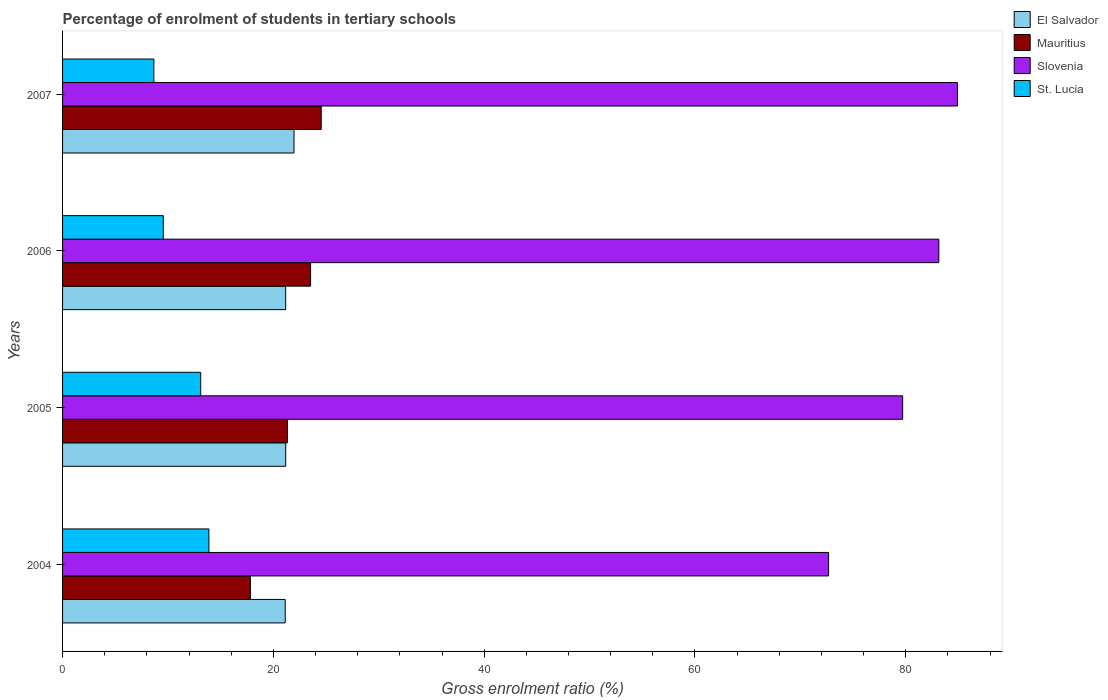How many bars are there on the 1st tick from the bottom?
Provide a succinct answer. 4. What is the percentage of students enrolled in tertiary schools in El Salvador in 2007?
Give a very brief answer. 21.96. Across all years, what is the maximum percentage of students enrolled in tertiary schools in Slovenia?
Keep it short and to the point. 84.91. Across all years, what is the minimum percentage of students enrolled in tertiary schools in Slovenia?
Keep it short and to the point. 72.68. In which year was the percentage of students enrolled in tertiary schools in El Salvador minimum?
Offer a very short reply. 2004. What is the total percentage of students enrolled in tertiary schools in El Salvador in the graph?
Keep it short and to the point. 85.42. What is the difference between the percentage of students enrolled in tertiary schools in Slovenia in 2004 and that in 2007?
Provide a succinct answer. -12.22. What is the difference between the percentage of students enrolled in tertiary schools in El Salvador in 2004 and the percentage of students enrolled in tertiary schools in St. Lucia in 2007?
Your answer should be very brief. 12.46. What is the average percentage of students enrolled in tertiary schools in St. Lucia per year?
Make the answer very short. 11.3. In the year 2004, what is the difference between the percentage of students enrolled in tertiary schools in Slovenia and percentage of students enrolled in tertiary schools in St. Lucia?
Keep it short and to the point. 58.8. What is the ratio of the percentage of students enrolled in tertiary schools in El Salvador in 2004 to that in 2007?
Make the answer very short. 0.96. Is the percentage of students enrolled in tertiary schools in Slovenia in 2004 less than that in 2007?
Give a very brief answer. Yes. What is the difference between the highest and the second highest percentage of students enrolled in tertiary schools in St. Lucia?
Provide a succinct answer. 0.78. What is the difference between the highest and the lowest percentage of students enrolled in tertiary schools in El Salvador?
Make the answer very short. 0.83. In how many years, is the percentage of students enrolled in tertiary schools in St. Lucia greater than the average percentage of students enrolled in tertiary schools in St. Lucia taken over all years?
Provide a short and direct response. 2. Is it the case that in every year, the sum of the percentage of students enrolled in tertiary schools in Mauritius and percentage of students enrolled in tertiary schools in St. Lucia is greater than the sum of percentage of students enrolled in tertiary schools in Slovenia and percentage of students enrolled in tertiary schools in El Salvador?
Your answer should be compact. Yes. What does the 3rd bar from the top in 2007 represents?
Your answer should be very brief. Mauritius. What does the 4th bar from the bottom in 2007 represents?
Provide a short and direct response. St. Lucia. Is it the case that in every year, the sum of the percentage of students enrolled in tertiary schools in Slovenia and percentage of students enrolled in tertiary schools in Mauritius is greater than the percentage of students enrolled in tertiary schools in St. Lucia?
Provide a succinct answer. Yes. Does the graph contain any zero values?
Your answer should be very brief. No. Does the graph contain grids?
Your answer should be compact. No. Where does the legend appear in the graph?
Your answer should be very brief. Top right. How many legend labels are there?
Ensure brevity in your answer.  4. What is the title of the graph?
Your response must be concise. Percentage of enrolment of students in tertiary schools. What is the label or title of the X-axis?
Make the answer very short. Gross enrolment ratio (%). What is the label or title of the Y-axis?
Offer a terse response. Years. What is the Gross enrolment ratio (%) of El Salvador in 2004?
Provide a succinct answer. 21.13. What is the Gross enrolment ratio (%) in Mauritius in 2004?
Offer a terse response. 17.82. What is the Gross enrolment ratio (%) of Slovenia in 2004?
Make the answer very short. 72.68. What is the Gross enrolment ratio (%) in St. Lucia in 2004?
Ensure brevity in your answer.  13.88. What is the Gross enrolment ratio (%) in El Salvador in 2005?
Provide a succinct answer. 21.17. What is the Gross enrolment ratio (%) of Mauritius in 2005?
Provide a short and direct response. 21.34. What is the Gross enrolment ratio (%) in Slovenia in 2005?
Ensure brevity in your answer.  79.71. What is the Gross enrolment ratio (%) in St. Lucia in 2005?
Keep it short and to the point. 13.11. What is the Gross enrolment ratio (%) of El Salvador in 2006?
Your answer should be compact. 21.17. What is the Gross enrolment ratio (%) in Mauritius in 2006?
Make the answer very short. 23.53. What is the Gross enrolment ratio (%) in Slovenia in 2006?
Your answer should be compact. 83.14. What is the Gross enrolment ratio (%) in St. Lucia in 2006?
Your response must be concise. 9.56. What is the Gross enrolment ratio (%) of El Salvador in 2007?
Offer a terse response. 21.96. What is the Gross enrolment ratio (%) in Mauritius in 2007?
Your answer should be compact. 24.54. What is the Gross enrolment ratio (%) of Slovenia in 2007?
Keep it short and to the point. 84.91. What is the Gross enrolment ratio (%) of St. Lucia in 2007?
Provide a short and direct response. 8.66. Across all years, what is the maximum Gross enrolment ratio (%) of El Salvador?
Offer a terse response. 21.96. Across all years, what is the maximum Gross enrolment ratio (%) of Mauritius?
Make the answer very short. 24.54. Across all years, what is the maximum Gross enrolment ratio (%) of Slovenia?
Your answer should be compact. 84.91. Across all years, what is the maximum Gross enrolment ratio (%) of St. Lucia?
Keep it short and to the point. 13.88. Across all years, what is the minimum Gross enrolment ratio (%) of El Salvador?
Your answer should be compact. 21.13. Across all years, what is the minimum Gross enrolment ratio (%) in Mauritius?
Your answer should be compact. 17.82. Across all years, what is the minimum Gross enrolment ratio (%) in Slovenia?
Provide a succinct answer. 72.68. Across all years, what is the minimum Gross enrolment ratio (%) in St. Lucia?
Provide a short and direct response. 8.66. What is the total Gross enrolment ratio (%) of El Salvador in the graph?
Provide a short and direct response. 85.42. What is the total Gross enrolment ratio (%) of Mauritius in the graph?
Your answer should be very brief. 87.23. What is the total Gross enrolment ratio (%) in Slovenia in the graph?
Make the answer very short. 320.43. What is the total Gross enrolment ratio (%) in St. Lucia in the graph?
Offer a terse response. 45.21. What is the difference between the Gross enrolment ratio (%) in El Salvador in 2004 and that in 2005?
Your answer should be very brief. -0.04. What is the difference between the Gross enrolment ratio (%) in Mauritius in 2004 and that in 2005?
Make the answer very short. -3.51. What is the difference between the Gross enrolment ratio (%) in Slovenia in 2004 and that in 2005?
Your answer should be compact. -7.03. What is the difference between the Gross enrolment ratio (%) in St. Lucia in 2004 and that in 2005?
Your answer should be very brief. 0.78. What is the difference between the Gross enrolment ratio (%) of El Salvador in 2004 and that in 2006?
Your answer should be compact. -0.04. What is the difference between the Gross enrolment ratio (%) of Mauritius in 2004 and that in 2006?
Your answer should be compact. -5.71. What is the difference between the Gross enrolment ratio (%) of Slovenia in 2004 and that in 2006?
Your answer should be compact. -10.46. What is the difference between the Gross enrolment ratio (%) of St. Lucia in 2004 and that in 2006?
Make the answer very short. 4.32. What is the difference between the Gross enrolment ratio (%) of El Salvador in 2004 and that in 2007?
Offer a terse response. -0.83. What is the difference between the Gross enrolment ratio (%) in Mauritius in 2004 and that in 2007?
Your response must be concise. -6.72. What is the difference between the Gross enrolment ratio (%) in Slovenia in 2004 and that in 2007?
Your answer should be very brief. -12.22. What is the difference between the Gross enrolment ratio (%) of St. Lucia in 2004 and that in 2007?
Your answer should be very brief. 5.22. What is the difference between the Gross enrolment ratio (%) of El Salvador in 2005 and that in 2006?
Provide a succinct answer. 0. What is the difference between the Gross enrolment ratio (%) in Mauritius in 2005 and that in 2006?
Make the answer very short. -2.2. What is the difference between the Gross enrolment ratio (%) of Slovenia in 2005 and that in 2006?
Offer a very short reply. -3.43. What is the difference between the Gross enrolment ratio (%) in St. Lucia in 2005 and that in 2006?
Your response must be concise. 3.55. What is the difference between the Gross enrolment ratio (%) of El Salvador in 2005 and that in 2007?
Your answer should be compact. -0.79. What is the difference between the Gross enrolment ratio (%) in Mauritius in 2005 and that in 2007?
Your answer should be compact. -3.2. What is the difference between the Gross enrolment ratio (%) of Slovenia in 2005 and that in 2007?
Make the answer very short. -5.2. What is the difference between the Gross enrolment ratio (%) of St. Lucia in 2005 and that in 2007?
Offer a terse response. 4.44. What is the difference between the Gross enrolment ratio (%) in El Salvador in 2006 and that in 2007?
Offer a very short reply. -0.8. What is the difference between the Gross enrolment ratio (%) of Mauritius in 2006 and that in 2007?
Keep it short and to the point. -1.01. What is the difference between the Gross enrolment ratio (%) in Slovenia in 2006 and that in 2007?
Your answer should be compact. -1.77. What is the difference between the Gross enrolment ratio (%) of St. Lucia in 2006 and that in 2007?
Make the answer very short. 0.89. What is the difference between the Gross enrolment ratio (%) of El Salvador in 2004 and the Gross enrolment ratio (%) of Mauritius in 2005?
Keep it short and to the point. -0.21. What is the difference between the Gross enrolment ratio (%) of El Salvador in 2004 and the Gross enrolment ratio (%) of Slovenia in 2005?
Your answer should be very brief. -58.58. What is the difference between the Gross enrolment ratio (%) in El Salvador in 2004 and the Gross enrolment ratio (%) in St. Lucia in 2005?
Keep it short and to the point. 8.02. What is the difference between the Gross enrolment ratio (%) in Mauritius in 2004 and the Gross enrolment ratio (%) in Slovenia in 2005?
Ensure brevity in your answer.  -61.89. What is the difference between the Gross enrolment ratio (%) in Mauritius in 2004 and the Gross enrolment ratio (%) in St. Lucia in 2005?
Give a very brief answer. 4.72. What is the difference between the Gross enrolment ratio (%) in Slovenia in 2004 and the Gross enrolment ratio (%) in St. Lucia in 2005?
Provide a short and direct response. 59.57. What is the difference between the Gross enrolment ratio (%) in El Salvador in 2004 and the Gross enrolment ratio (%) in Mauritius in 2006?
Your answer should be very brief. -2.41. What is the difference between the Gross enrolment ratio (%) of El Salvador in 2004 and the Gross enrolment ratio (%) of Slovenia in 2006?
Make the answer very short. -62.01. What is the difference between the Gross enrolment ratio (%) of El Salvador in 2004 and the Gross enrolment ratio (%) of St. Lucia in 2006?
Ensure brevity in your answer.  11.57. What is the difference between the Gross enrolment ratio (%) of Mauritius in 2004 and the Gross enrolment ratio (%) of Slovenia in 2006?
Your answer should be compact. -65.32. What is the difference between the Gross enrolment ratio (%) in Mauritius in 2004 and the Gross enrolment ratio (%) in St. Lucia in 2006?
Make the answer very short. 8.26. What is the difference between the Gross enrolment ratio (%) of Slovenia in 2004 and the Gross enrolment ratio (%) of St. Lucia in 2006?
Your response must be concise. 63.12. What is the difference between the Gross enrolment ratio (%) of El Salvador in 2004 and the Gross enrolment ratio (%) of Mauritius in 2007?
Your answer should be compact. -3.41. What is the difference between the Gross enrolment ratio (%) of El Salvador in 2004 and the Gross enrolment ratio (%) of Slovenia in 2007?
Give a very brief answer. -63.78. What is the difference between the Gross enrolment ratio (%) of El Salvador in 2004 and the Gross enrolment ratio (%) of St. Lucia in 2007?
Make the answer very short. 12.46. What is the difference between the Gross enrolment ratio (%) in Mauritius in 2004 and the Gross enrolment ratio (%) in Slovenia in 2007?
Offer a terse response. -67.08. What is the difference between the Gross enrolment ratio (%) of Mauritius in 2004 and the Gross enrolment ratio (%) of St. Lucia in 2007?
Your answer should be very brief. 9.16. What is the difference between the Gross enrolment ratio (%) of Slovenia in 2004 and the Gross enrolment ratio (%) of St. Lucia in 2007?
Offer a very short reply. 64.02. What is the difference between the Gross enrolment ratio (%) of El Salvador in 2005 and the Gross enrolment ratio (%) of Mauritius in 2006?
Offer a terse response. -2.36. What is the difference between the Gross enrolment ratio (%) in El Salvador in 2005 and the Gross enrolment ratio (%) in Slovenia in 2006?
Ensure brevity in your answer.  -61.97. What is the difference between the Gross enrolment ratio (%) in El Salvador in 2005 and the Gross enrolment ratio (%) in St. Lucia in 2006?
Your answer should be very brief. 11.61. What is the difference between the Gross enrolment ratio (%) of Mauritius in 2005 and the Gross enrolment ratio (%) of Slovenia in 2006?
Keep it short and to the point. -61.8. What is the difference between the Gross enrolment ratio (%) in Mauritius in 2005 and the Gross enrolment ratio (%) in St. Lucia in 2006?
Offer a terse response. 11.78. What is the difference between the Gross enrolment ratio (%) of Slovenia in 2005 and the Gross enrolment ratio (%) of St. Lucia in 2006?
Keep it short and to the point. 70.15. What is the difference between the Gross enrolment ratio (%) of El Salvador in 2005 and the Gross enrolment ratio (%) of Mauritius in 2007?
Provide a short and direct response. -3.37. What is the difference between the Gross enrolment ratio (%) of El Salvador in 2005 and the Gross enrolment ratio (%) of Slovenia in 2007?
Provide a short and direct response. -63.74. What is the difference between the Gross enrolment ratio (%) in El Salvador in 2005 and the Gross enrolment ratio (%) in St. Lucia in 2007?
Offer a very short reply. 12.51. What is the difference between the Gross enrolment ratio (%) in Mauritius in 2005 and the Gross enrolment ratio (%) in Slovenia in 2007?
Ensure brevity in your answer.  -63.57. What is the difference between the Gross enrolment ratio (%) of Mauritius in 2005 and the Gross enrolment ratio (%) of St. Lucia in 2007?
Give a very brief answer. 12.67. What is the difference between the Gross enrolment ratio (%) in Slovenia in 2005 and the Gross enrolment ratio (%) in St. Lucia in 2007?
Offer a very short reply. 71.04. What is the difference between the Gross enrolment ratio (%) of El Salvador in 2006 and the Gross enrolment ratio (%) of Mauritius in 2007?
Your response must be concise. -3.37. What is the difference between the Gross enrolment ratio (%) of El Salvador in 2006 and the Gross enrolment ratio (%) of Slovenia in 2007?
Make the answer very short. -63.74. What is the difference between the Gross enrolment ratio (%) in El Salvador in 2006 and the Gross enrolment ratio (%) in St. Lucia in 2007?
Provide a short and direct response. 12.5. What is the difference between the Gross enrolment ratio (%) of Mauritius in 2006 and the Gross enrolment ratio (%) of Slovenia in 2007?
Offer a very short reply. -61.37. What is the difference between the Gross enrolment ratio (%) in Mauritius in 2006 and the Gross enrolment ratio (%) in St. Lucia in 2007?
Keep it short and to the point. 14.87. What is the difference between the Gross enrolment ratio (%) in Slovenia in 2006 and the Gross enrolment ratio (%) in St. Lucia in 2007?
Your answer should be very brief. 74.48. What is the average Gross enrolment ratio (%) in El Salvador per year?
Your answer should be compact. 21.36. What is the average Gross enrolment ratio (%) of Mauritius per year?
Provide a succinct answer. 21.81. What is the average Gross enrolment ratio (%) in Slovenia per year?
Your response must be concise. 80.11. What is the average Gross enrolment ratio (%) in St. Lucia per year?
Give a very brief answer. 11.3. In the year 2004, what is the difference between the Gross enrolment ratio (%) of El Salvador and Gross enrolment ratio (%) of Mauritius?
Give a very brief answer. 3.3. In the year 2004, what is the difference between the Gross enrolment ratio (%) of El Salvador and Gross enrolment ratio (%) of Slovenia?
Offer a very short reply. -51.55. In the year 2004, what is the difference between the Gross enrolment ratio (%) of El Salvador and Gross enrolment ratio (%) of St. Lucia?
Keep it short and to the point. 7.24. In the year 2004, what is the difference between the Gross enrolment ratio (%) in Mauritius and Gross enrolment ratio (%) in Slovenia?
Your answer should be compact. -54.86. In the year 2004, what is the difference between the Gross enrolment ratio (%) in Mauritius and Gross enrolment ratio (%) in St. Lucia?
Offer a very short reply. 3.94. In the year 2004, what is the difference between the Gross enrolment ratio (%) in Slovenia and Gross enrolment ratio (%) in St. Lucia?
Keep it short and to the point. 58.8. In the year 2005, what is the difference between the Gross enrolment ratio (%) in El Salvador and Gross enrolment ratio (%) in Mauritius?
Your answer should be very brief. -0.17. In the year 2005, what is the difference between the Gross enrolment ratio (%) of El Salvador and Gross enrolment ratio (%) of Slovenia?
Give a very brief answer. -58.54. In the year 2005, what is the difference between the Gross enrolment ratio (%) of El Salvador and Gross enrolment ratio (%) of St. Lucia?
Your answer should be very brief. 8.06. In the year 2005, what is the difference between the Gross enrolment ratio (%) of Mauritius and Gross enrolment ratio (%) of Slovenia?
Give a very brief answer. -58.37. In the year 2005, what is the difference between the Gross enrolment ratio (%) in Mauritius and Gross enrolment ratio (%) in St. Lucia?
Make the answer very short. 8.23. In the year 2005, what is the difference between the Gross enrolment ratio (%) of Slovenia and Gross enrolment ratio (%) of St. Lucia?
Ensure brevity in your answer.  66.6. In the year 2006, what is the difference between the Gross enrolment ratio (%) of El Salvador and Gross enrolment ratio (%) of Mauritius?
Keep it short and to the point. -2.37. In the year 2006, what is the difference between the Gross enrolment ratio (%) in El Salvador and Gross enrolment ratio (%) in Slovenia?
Provide a short and direct response. -61.97. In the year 2006, what is the difference between the Gross enrolment ratio (%) in El Salvador and Gross enrolment ratio (%) in St. Lucia?
Make the answer very short. 11.61. In the year 2006, what is the difference between the Gross enrolment ratio (%) of Mauritius and Gross enrolment ratio (%) of Slovenia?
Offer a very short reply. -59.61. In the year 2006, what is the difference between the Gross enrolment ratio (%) of Mauritius and Gross enrolment ratio (%) of St. Lucia?
Give a very brief answer. 13.97. In the year 2006, what is the difference between the Gross enrolment ratio (%) in Slovenia and Gross enrolment ratio (%) in St. Lucia?
Offer a terse response. 73.58. In the year 2007, what is the difference between the Gross enrolment ratio (%) in El Salvador and Gross enrolment ratio (%) in Mauritius?
Give a very brief answer. -2.58. In the year 2007, what is the difference between the Gross enrolment ratio (%) in El Salvador and Gross enrolment ratio (%) in Slovenia?
Offer a terse response. -62.94. In the year 2007, what is the difference between the Gross enrolment ratio (%) in El Salvador and Gross enrolment ratio (%) in St. Lucia?
Provide a succinct answer. 13.3. In the year 2007, what is the difference between the Gross enrolment ratio (%) in Mauritius and Gross enrolment ratio (%) in Slovenia?
Give a very brief answer. -60.37. In the year 2007, what is the difference between the Gross enrolment ratio (%) of Mauritius and Gross enrolment ratio (%) of St. Lucia?
Offer a very short reply. 15.88. In the year 2007, what is the difference between the Gross enrolment ratio (%) in Slovenia and Gross enrolment ratio (%) in St. Lucia?
Keep it short and to the point. 76.24. What is the ratio of the Gross enrolment ratio (%) of El Salvador in 2004 to that in 2005?
Make the answer very short. 1. What is the ratio of the Gross enrolment ratio (%) in Mauritius in 2004 to that in 2005?
Your answer should be very brief. 0.84. What is the ratio of the Gross enrolment ratio (%) of Slovenia in 2004 to that in 2005?
Keep it short and to the point. 0.91. What is the ratio of the Gross enrolment ratio (%) of St. Lucia in 2004 to that in 2005?
Provide a succinct answer. 1.06. What is the ratio of the Gross enrolment ratio (%) of El Salvador in 2004 to that in 2006?
Keep it short and to the point. 1. What is the ratio of the Gross enrolment ratio (%) of Mauritius in 2004 to that in 2006?
Your response must be concise. 0.76. What is the ratio of the Gross enrolment ratio (%) of Slovenia in 2004 to that in 2006?
Your answer should be very brief. 0.87. What is the ratio of the Gross enrolment ratio (%) of St. Lucia in 2004 to that in 2006?
Keep it short and to the point. 1.45. What is the ratio of the Gross enrolment ratio (%) of El Salvador in 2004 to that in 2007?
Ensure brevity in your answer.  0.96. What is the ratio of the Gross enrolment ratio (%) of Mauritius in 2004 to that in 2007?
Provide a short and direct response. 0.73. What is the ratio of the Gross enrolment ratio (%) in Slovenia in 2004 to that in 2007?
Your response must be concise. 0.86. What is the ratio of the Gross enrolment ratio (%) of St. Lucia in 2004 to that in 2007?
Your answer should be compact. 1.6. What is the ratio of the Gross enrolment ratio (%) in El Salvador in 2005 to that in 2006?
Ensure brevity in your answer.  1. What is the ratio of the Gross enrolment ratio (%) in Mauritius in 2005 to that in 2006?
Ensure brevity in your answer.  0.91. What is the ratio of the Gross enrolment ratio (%) of Slovenia in 2005 to that in 2006?
Ensure brevity in your answer.  0.96. What is the ratio of the Gross enrolment ratio (%) of St. Lucia in 2005 to that in 2006?
Your answer should be very brief. 1.37. What is the ratio of the Gross enrolment ratio (%) of El Salvador in 2005 to that in 2007?
Provide a succinct answer. 0.96. What is the ratio of the Gross enrolment ratio (%) of Mauritius in 2005 to that in 2007?
Provide a succinct answer. 0.87. What is the ratio of the Gross enrolment ratio (%) in Slovenia in 2005 to that in 2007?
Your answer should be very brief. 0.94. What is the ratio of the Gross enrolment ratio (%) of St. Lucia in 2005 to that in 2007?
Provide a succinct answer. 1.51. What is the ratio of the Gross enrolment ratio (%) in El Salvador in 2006 to that in 2007?
Ensure brevity in your answer.  0.96. What is the ratio of the Gross enrolment ratio (%) in Slovenia in 2006 to that in 2007?
Provide a short and direct response. 0.98. What is the ratio of the Gross enrolment ratio (%) of St. Lucia in 2006 to that in 2007?
Provide a succinct answer. 1.1. What is the difference between the highest and the second highest Gross enrolment ratio (%) in El Salvador?
Ensure brevity in your answer.  0.79. What is the difference between the highest and the second highest Gross enrolment ratio (%) in Slovenia?
Your answer should be very brief. 1.77. What is the difference between the highest and the second highest Gross enrolment ratio (%) in St. Lucia?
Give a very brief answer. 0.78. What is the difference between the highest and the lowest Gross enrolment ratio (%) in El Salvador?
Offer a very short reply. 0.83. What is the difference between the highest and the lowest Gross enrolment ratio (%) in Mauritius?
Your response must be concise. 6.72. What is the difference between the highest and the lowest Gross enrolment ratio (%) of Slovenia?
Your answer should be very brief. 12.22. What is the difference between the highest and the lowest Gross enrolment ratio (%) in St. Lucia?
Provide a short and direct response. 5.22. 